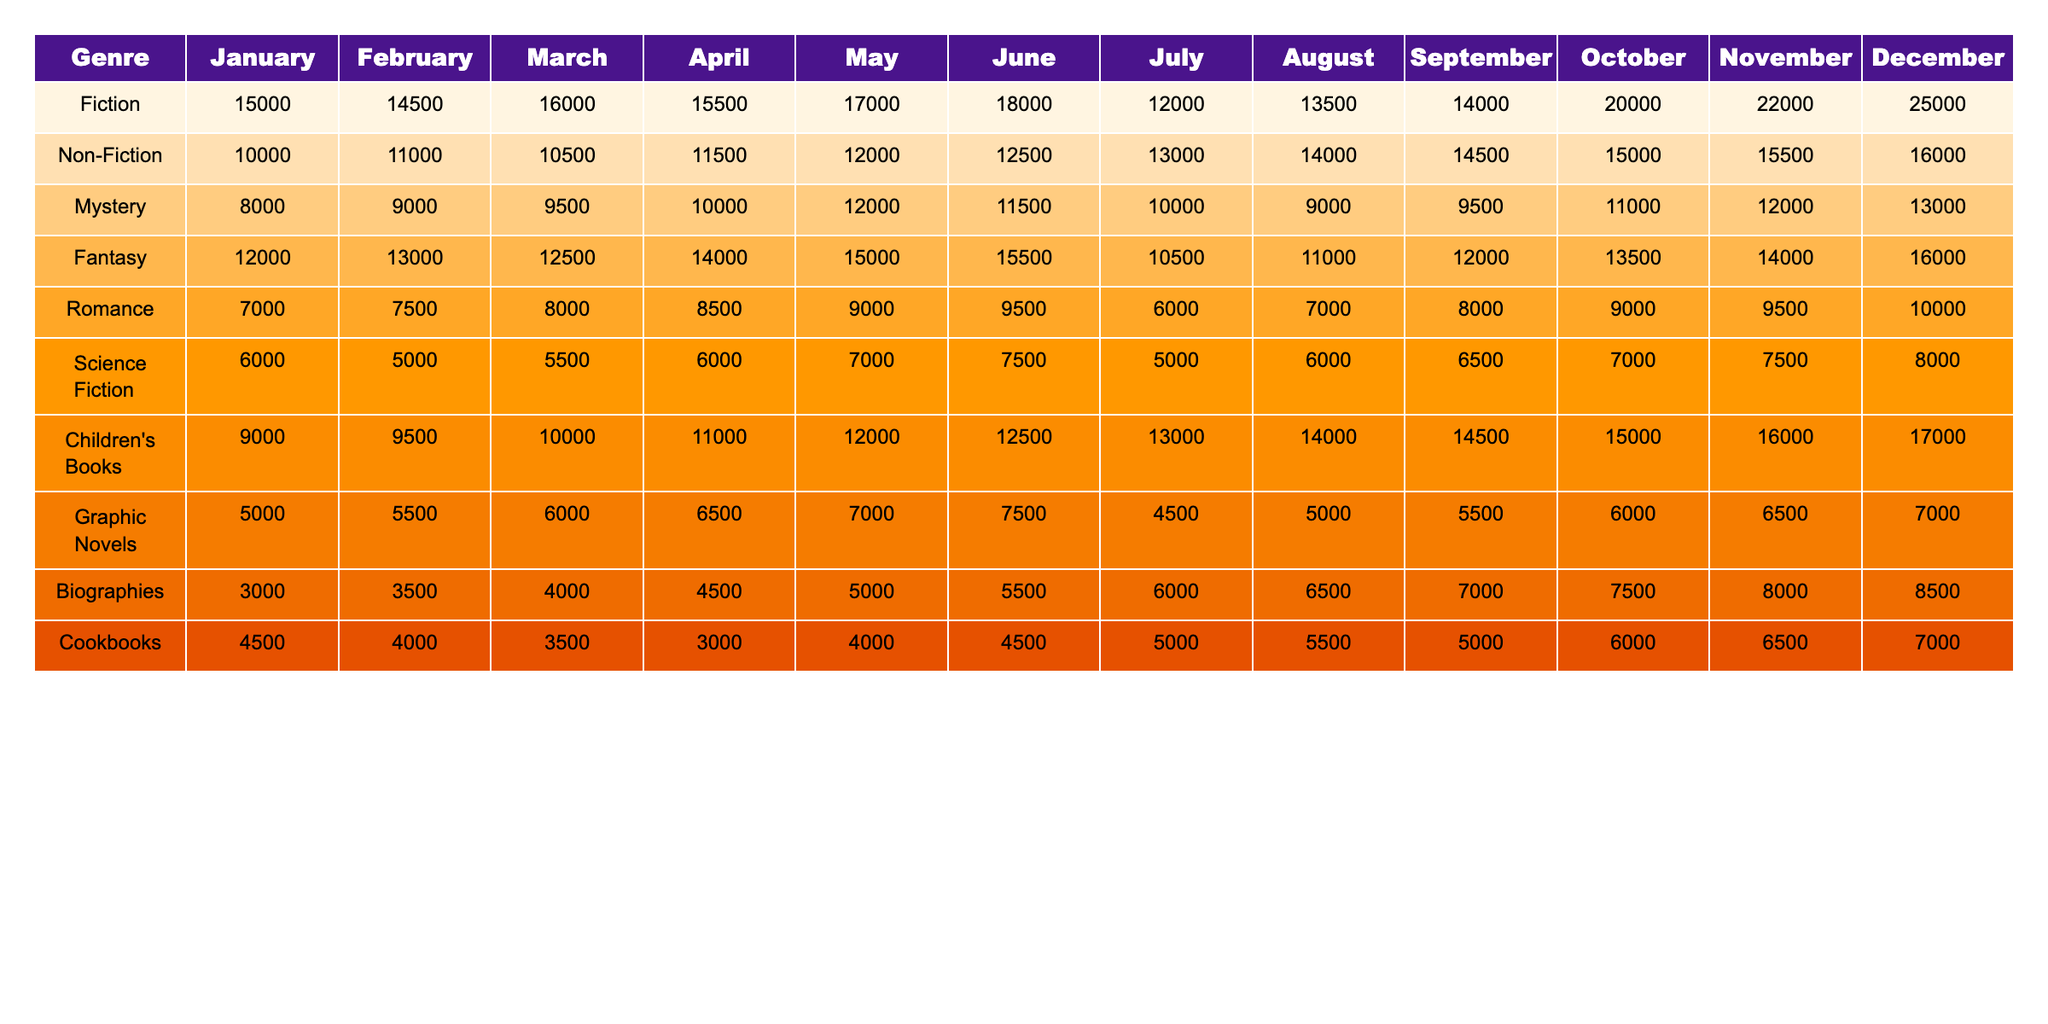What's the total number of Fiction books sold in May? By checking the table under the Fiction genre for May, we find the value 17000, which represents the total number of Fiction books sold.
Answer: 17000 Which genre had the highest sales in December? Observing the table for December, we see that Fiction had sales of 25000, which is higher than any other genre.
Answer: Fiction What is the difference in sales between Non-Fiction in November and October? For Non-Fiction, the sales in November are 15500, and in October they are 15000. The difference is 15500 - 15000 = 500.
Answer: 500 What is the average number of Children's Books sold over the year? We sum the sales for Children's Books across all months: (9000 + 9500 + 10000 + 11000 + 12000 + 12500 + 13000 + 14000 + 14500 + 15000 + 16000 + 17000) = 143000. Dividing by 12 months gives us 143000 / 12 = 11916.67, rounding gives approximately 11917.
Answer: 11917 Did Mystery sales ever reach 13000 units in any month? Looking through the Mystery sales data, the maximum value reached is 13000 in December, confirming that it did reach this amount.
Answer: Yes What was the peak sales month for Romance books? Reviewing the table, Romance sales peaked at 10000 units in December. We can confirm this by analyzing the monthly sales figures.
Answer: December In which month did Graphic Novels experience their lowest sales? Checking the data for Graphic Novels, we observe the lowest sales were in July at 4500 units.
Answer: July What was the total sales for Science Fiction from January to March? Adding the sales for Science Fiction across those three months gives: 6000 (January) + 5000 (February) + 5500 (March) = 16500.
Answer: 16500 How much more did Fantasy books sell in October compared to March? In October, Fantasy book sales were 13500 and in March, they were 12500. The difference is 13500 - 12500 = 1000.
Answer: 1000 What genre had a consistent growth in sales every month? Analyzing the sales figures, Non-Fiction shows a steady increase each month without any decline or plateau.
Answer: Non-Fiction Over the entire year, which genre had the least total sales? By summing up all the monthly sales for each genre, cookbooks had the least total sales: (4500 + 4000 + 3500 + 3000 + 4000 + 4500 + 5000 + 5500 + 5000 + 6000 + 6500 + 7000) = 48500, which is less than any other genre.
Answer: Cookbooks 